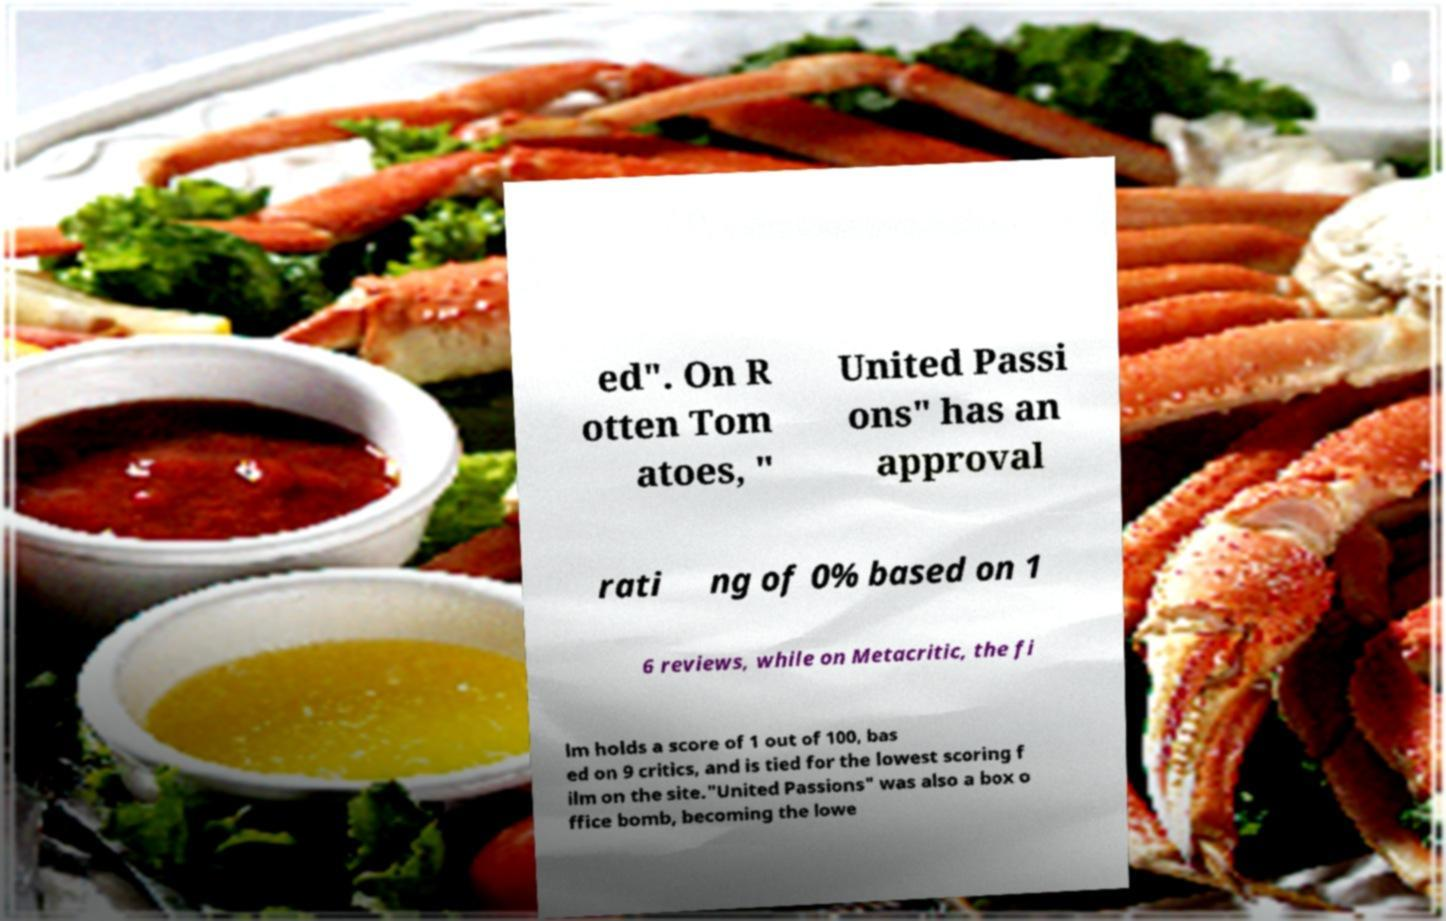Please identify and transcribe the text found in this image. ed". On R otten Tom atoes, " United Passi ons" has an approval rati ng of 0% based on 1 6 reviews, while on Metacritic, the fi lm holds a score of 1 out of 100, bas ed on 9 critics, and is tied for the lowest scoring f ilm on the site."United Passions" was also a box o ffice bomb, becoming the lowe 